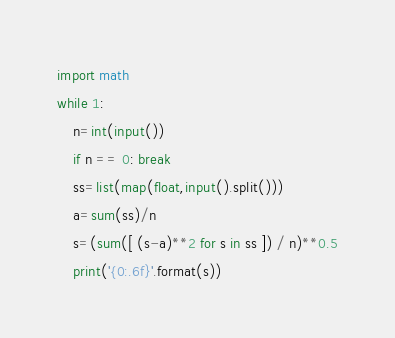Convert code to text. <code><loc_0><loc_0><loc_500><loc_500><_Python_>import math
while 1:
    n=int(input())
    if n == 0: break 
    ss=list(map(float,input().split()))
    a=sum(ss)/n
    s=(sum([ (s-a)**2 for s in ss ]) / n)**0.5
    print('{0:.6f}'.format(s))</code> 